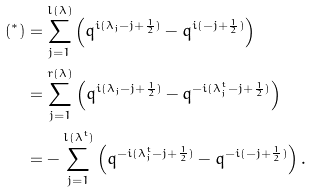Convert formula to latex. <formula><loc_0><loc_0><loc_500><loc_500>( ^ { * } ) & = \sum _ { j = 1 } ^ { l ( \lambda ) } \left ( q ^ { i ( \lambda _ { j } - j + \frac { 1 } { 2 } ) } - q ^ { i ( - j + \frac { 1 } { 2 } ) } \right ) \\ & = \sum _ { j = 1 } ^ { r ( \lambda ) } \left ( q ^ { i ( \lambda _ { j } - j + \frac { 1 } { 2 } ) } - q ^ { - i ( \lambda _ { j } ^ { t } - j + \frac { 1 } { 2 } ) } \right ) \\ & = - \sum _ { j = 1 } ^ { l ( \lambda ^ { t } ) } \left ( q ^ { - i ( \lambda _ { j } ^ { t } - j + \frac { 1 } { 2 } ) } - q ^ { - i ( - j + \frac { 1 } { 2 } ) } \right ) .</formula> 